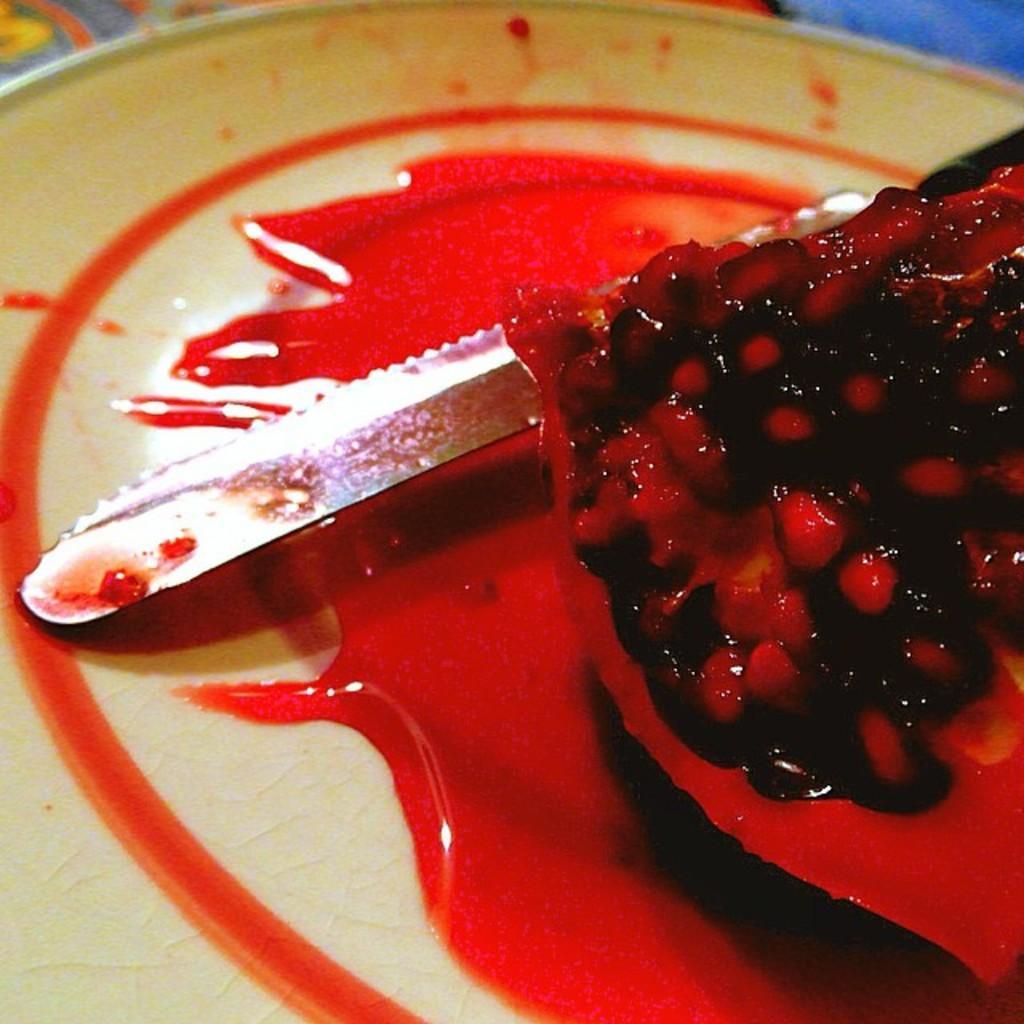How would you summarize this image in a sentence or two? In this picture we can see a pomegranate and a knife in the plate. 